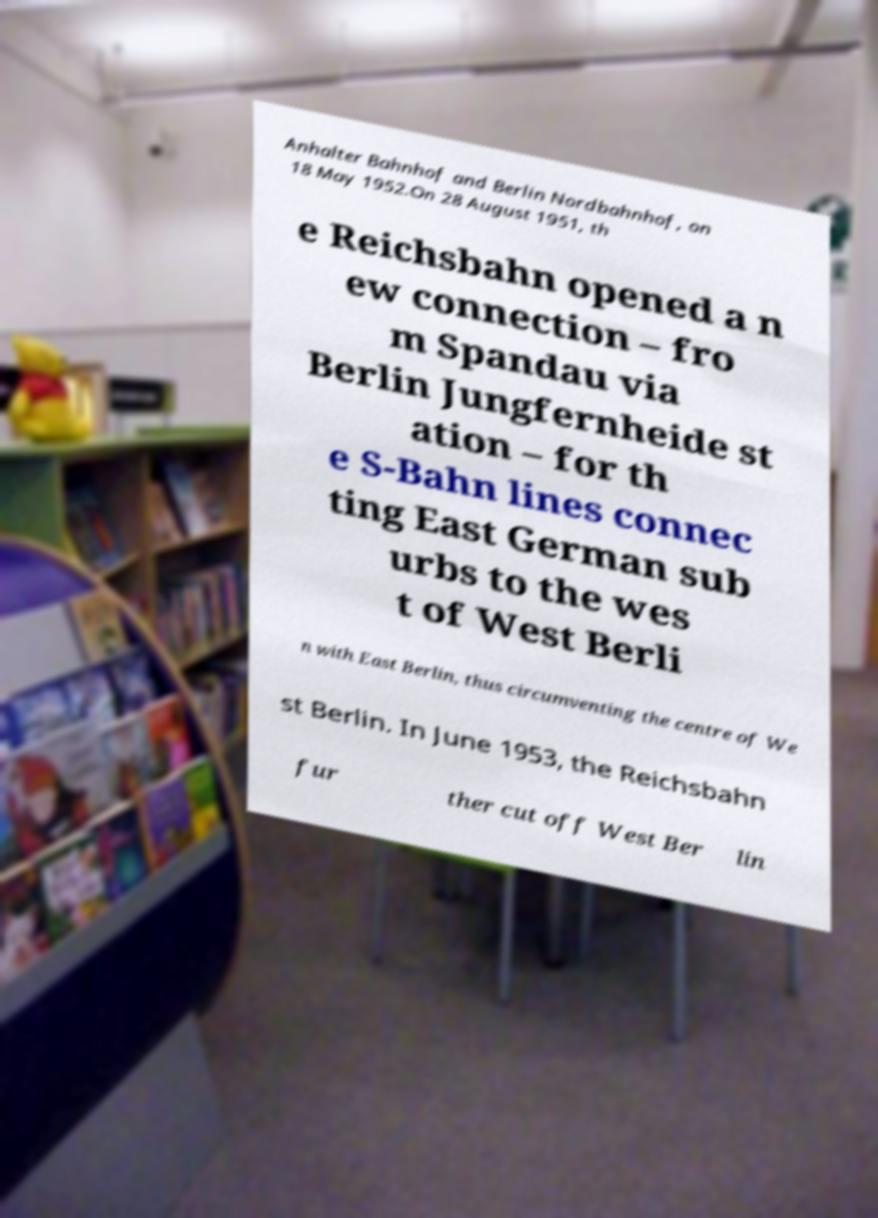Please identify and transcribe the text found in this image. Anhalter Bahnhof and Berlin Nordbahnhof, on 18 May 1952.On 28 August 1951, th e Reichsbahn opened a n ew connection – fro m Spandau via Berlin Jungfernheide st ation – for th e S-Bahn lines connec ting East German sub urbs to the wes t of West Berli n with East Berlin, thus circumventing the centre of We st Berlin. In June 1953, the Reichsbahn fur ther cut off West Ber lin 